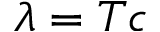<formula> <loc_0><loc_0><loc_500><loc_500>\lambda = T c</formula> 